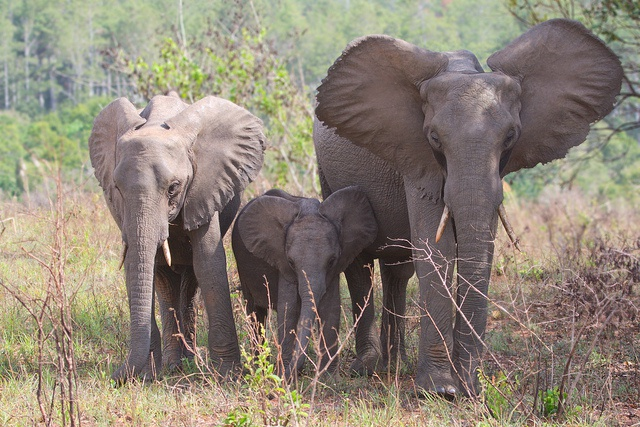Describe the objects in this image and their specific colors. I can see elephant in darkgray, gray, and black tones, elephant in darkgray, gray, and lightgray tones, and elephant in darkgray, gray, and black tones in this image. 